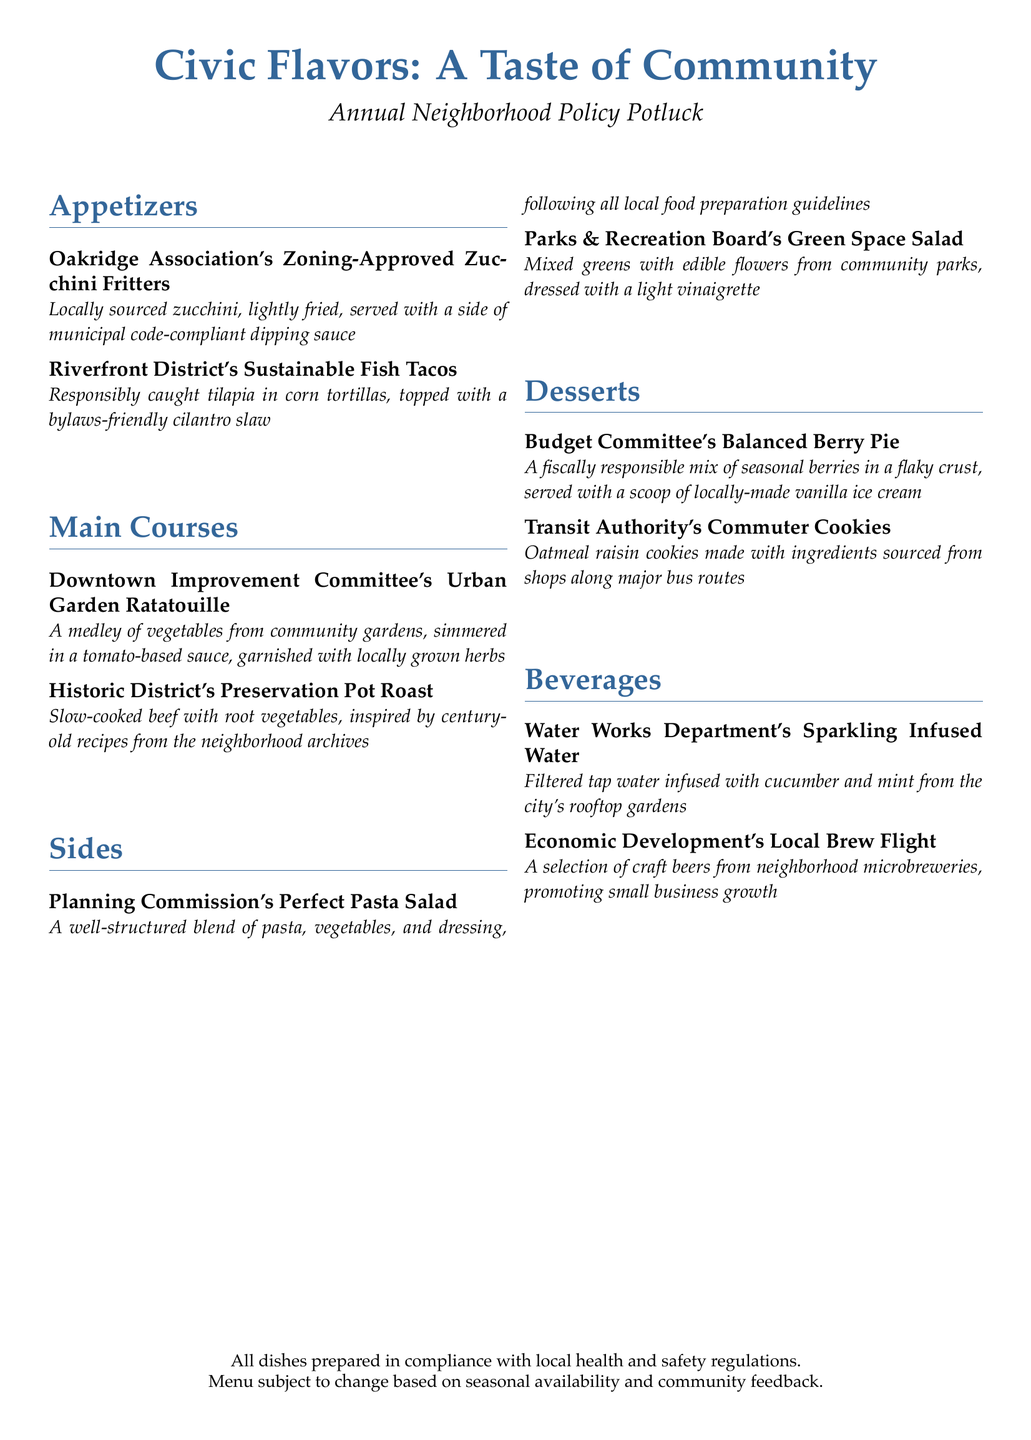What is the title of the menu? The title is prominently displayed at the top of the menu, highlighting the theme of the event.
Answer: Civic Flavors: A Taste of Community How many main courses are listed? The main courses section includes two distinct dishes detailed in the menu.
Answer: 2 Which appetizer features sustainably sourced fish? The menu states the name of the specific appetizer related to sustainable practices.
Answer: Riverfront District's Sustainable Fish Tacos What dessert is associated with the Budget Committee? This dessert is named within the desserts section, linking it to the committee's focus.
Answer: Balanced Berry Pie What unique ingredient is used in the Parks & Recreation Board's salad? The menu describes special ingredients that are sourced from community parks in relation to the salad.
Answer: Edible flowers Which beverage promotes small business growth? The beverage selection is explicitly connected to local economic development efforts.
Answer: Local Brew Flight What is the cooking method used for the Historic District's Preservation Pot Roast? The method used is clearly stated as part of the dish description in the main courses section.
Answer: Slow-cooked What is one key ingredient in the Planning Commission's pasta salad? This pasta dish's description includes several components that make it compliant with guidelines.
Answer: Vegetables 